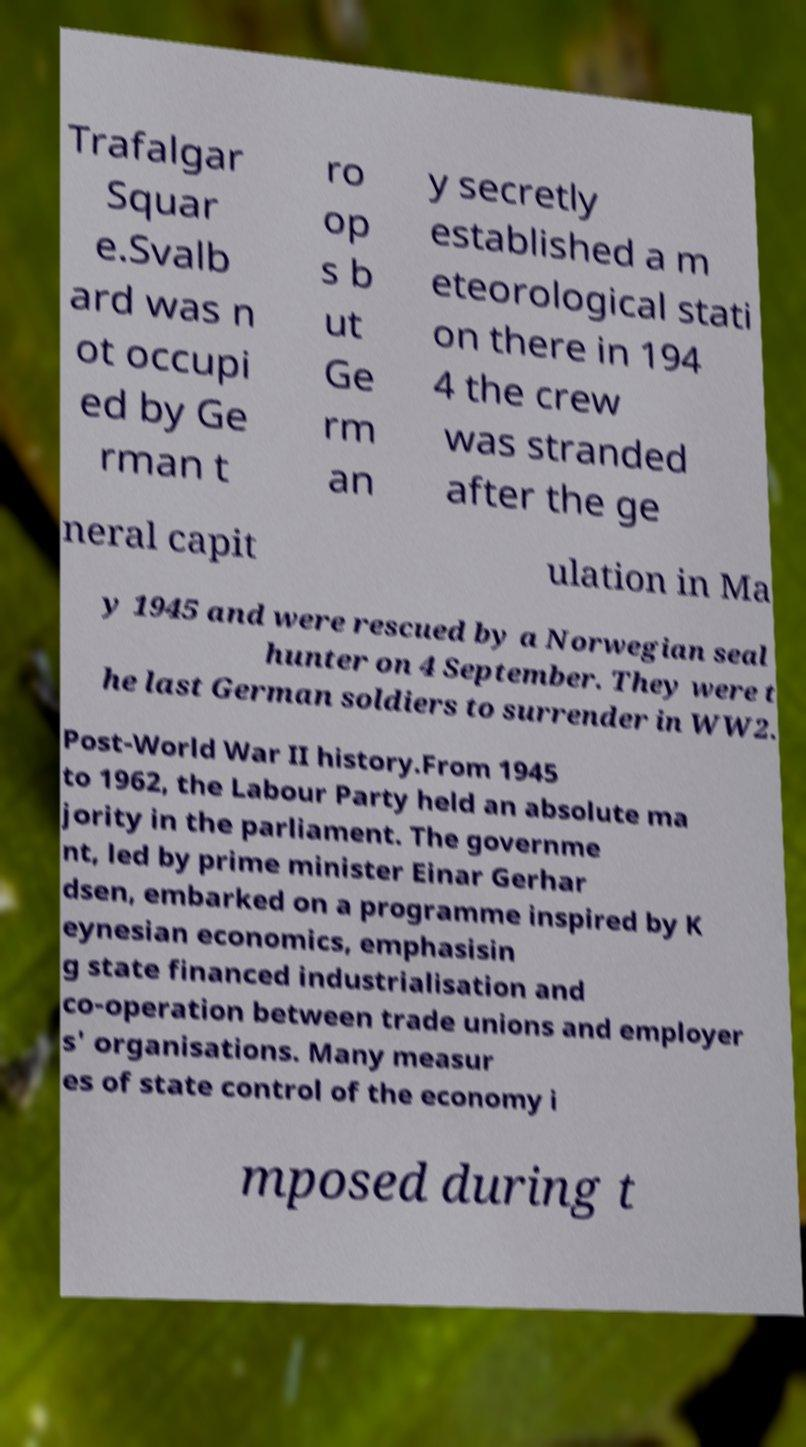Please identify and transcribe the text found in this image. Trafalgar Squar e.Svalb ard was n ot occupi ed by Ge rman t ro op s b ut Ge rm an y secretly established a m eteorological stati on there in 194 4 the crew was stranded after the ge neral capit ulation in Ma y 1945 and were rescued by a Norwegian seal hunter on 4 September. They were t he last German soldiers to surrender in WW2. Post-World War II history.From 1945 to 1962, the Labour Party held an absolute ma jority in the parliament. The governme nt, led by prime minister Einar Gerhar dsen, embarked on a programme inspired by K eynesian economics, emphasisin g state financed industrialisation and co-operation between trade unions and employer s' organisations. Many measur es of state control of the economy i mposed during t 